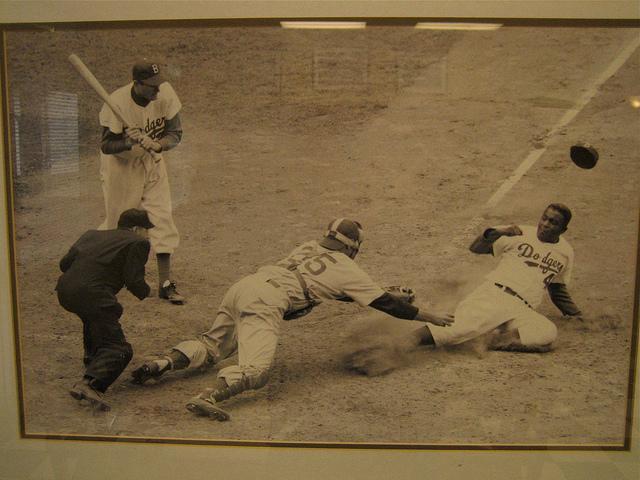What person is sliding?
Select the accurate answer and provide justification: `Answer: choice
Rationale: srationale.`
Options: Jackie chan, jackie brown, jackie kennedy, jackie robinson. Answer: jackie robinson.
Rationale: The man sliding is the name of him. 